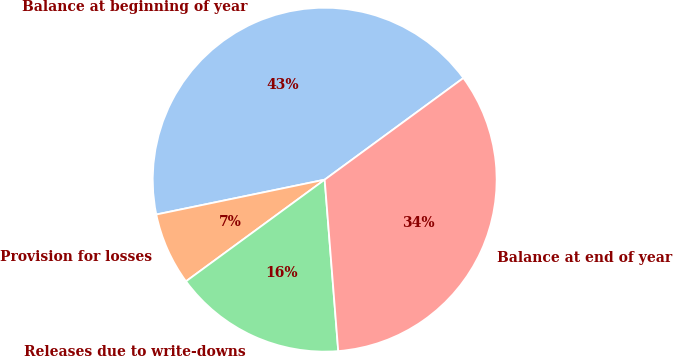Convert chart. <chart><loc_0><loc_0><loc_500><loc_500><pie_chart><fcel>Balance at beginning of year<fcel>Provision for losses<fcel>Releases due to write-downs<fcel>Balance at end of year<nl><fcel>43.18%<fcel>6.82%<fcel>16.19%<fcel>33.81%<nl></chart> 